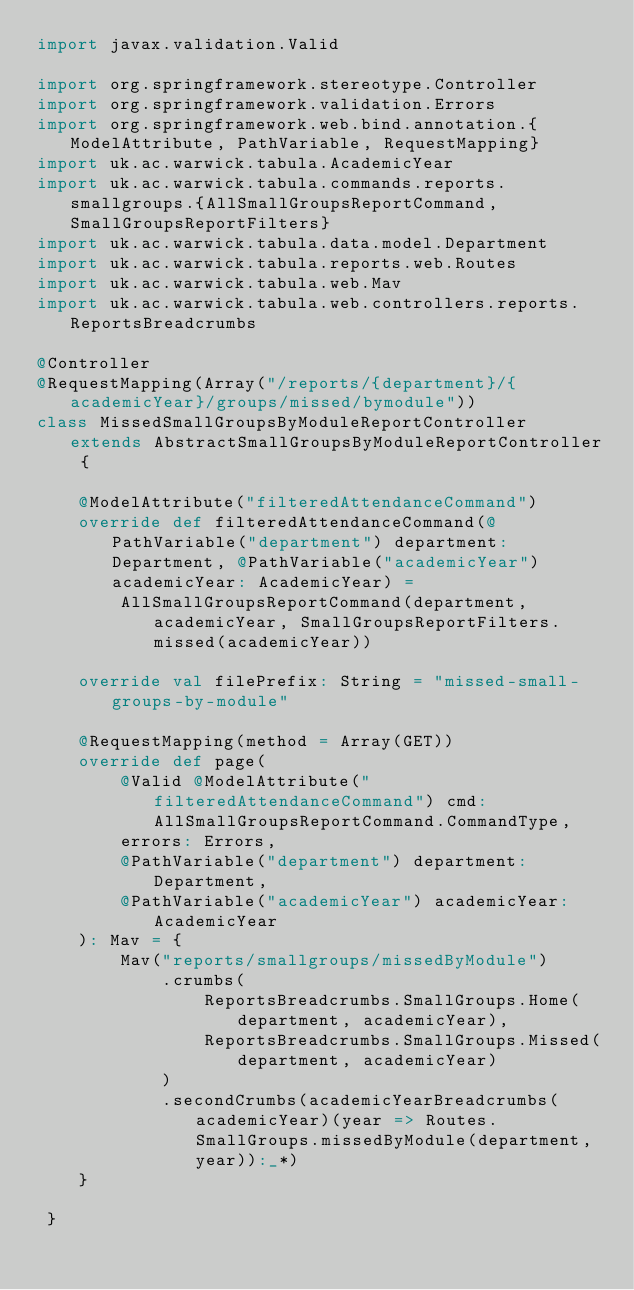Convert code to text. <code><loc_0><loc_0><loc_500><loc_500><_Scala_>import javax.validation.Valid

import org.springframework.stereotype.Controller
import org.springframework.validation.Errors
import org.springframework.web.bind.annotation.{ModelAttribute, PathVariable, RequestMapping}
import uk.ac.warwick.tabula.AcademicYear
import uk.ac.warwick.tabula.commands.reports.smallgroups.{AllSmallGroupsReportCommand, SmallGroupsReportFilters}
import uk.ac.warwick.tabula.data.model.Department
import uk.ac.warwick.tabula.reports.web.Routes
import uk.ac.warwick.tabula.web.Mav
import uk.ac.warwick.tabula.web.controllers.reports.ReportsBreadcrumbs

@Controller
@RequestMapping(Array("/reports/{department}/{academicYear}/groups/missed/bymodule"))
class MissedSmallGroupsByModuleReportController extends AbstractSmallGroupsByModuleReportController {

	@ModelAttribute("filteredAttendanceCommand")
	override def filteredAttendanceCommand(@PathVariable("department") department: Department, @PathVariable("academicYear") academicYear: AcademicYear) =
		AllSmallGroupsReportCommand(department, academicYear, SmallGroupsReportFilters.missed(academicYear))

	override val filePrefix: String = "missed-small-groups-by-module"

	@RequestMapping(method = Array(GET))
	override def page(
		@Valid @ModelAttribute("filteredAttendanceCommand") cmd: AllSmallGroupsReportCommand.CommandType,
		errors: Errors,
		@PathVariable("department") department: Department,
		@PathVariable("academicYear") academicYear: AcademicYear
	): Mav = {
		Mav("reports/smallgroups/missedByModule")
			.crumbs(
				ReportsBreadcrumbs.SmallGroups.Home(department, academicYear),
				ReportsBreadcrumbs.SmallGroups.Missed(department, academicYear)
			)
			.secondCrumbs(academicYearBreadcrumbs(academicYear)(year => Routes.SmallGroups.missedByModule(department, year)):_*)
	}

 }
</code> 